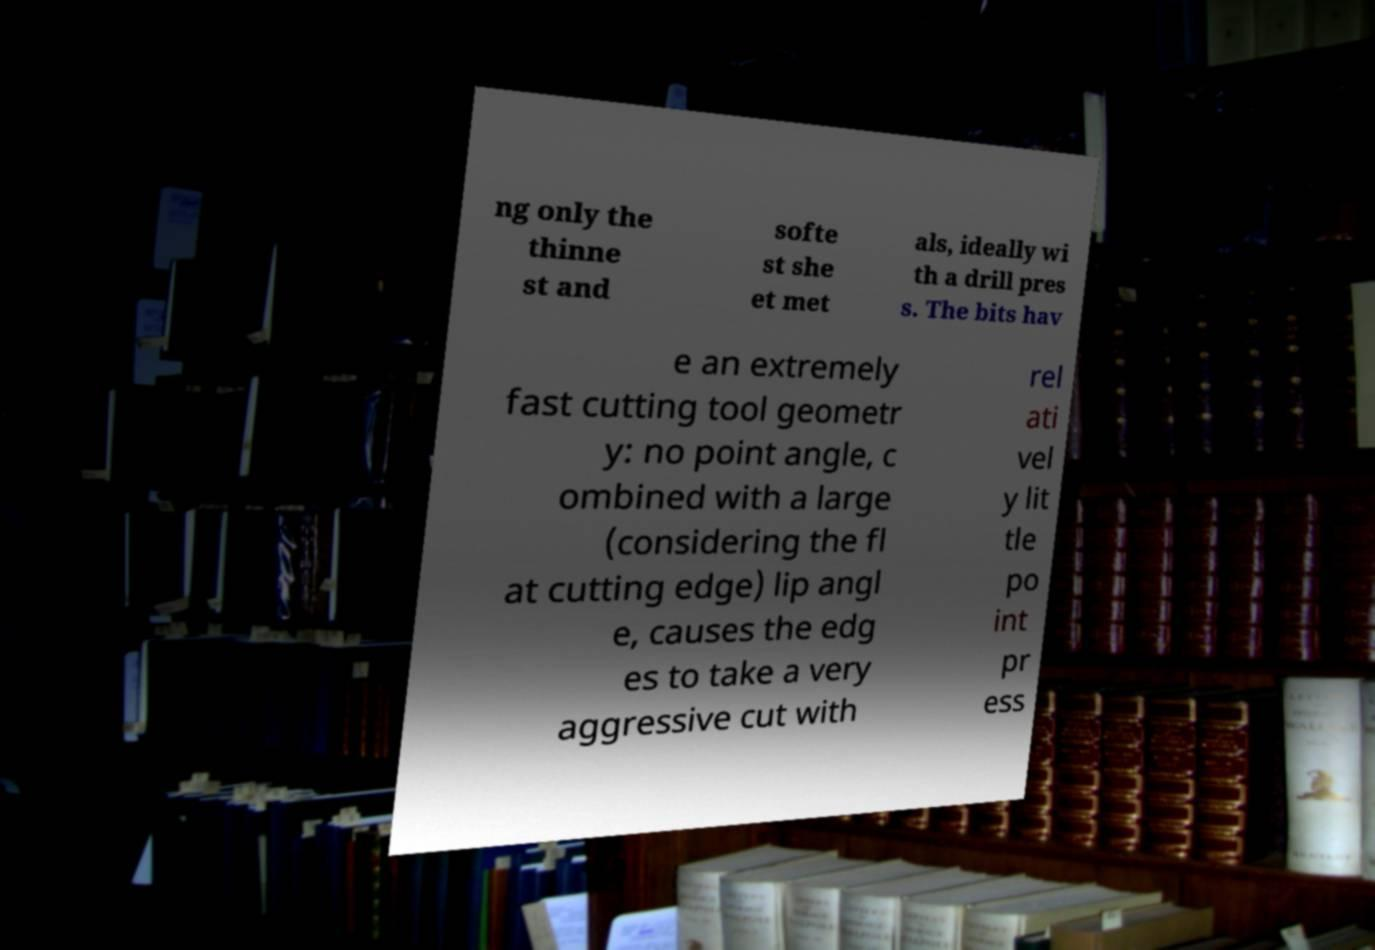There's text embedded in this image that I need extracted. Can you transcribe it verbatim? ng only the thinne st and softe st she et met als, ideally wi th a drill pres s. The bits hav e an extremely fast cutting tool geometr y: no point angle, c ombined with a large (considering the fl at cutting edge) lip angl e, causes the edg es to take a very aggressive cut with rel ati vel y lit tle po int pr ess 